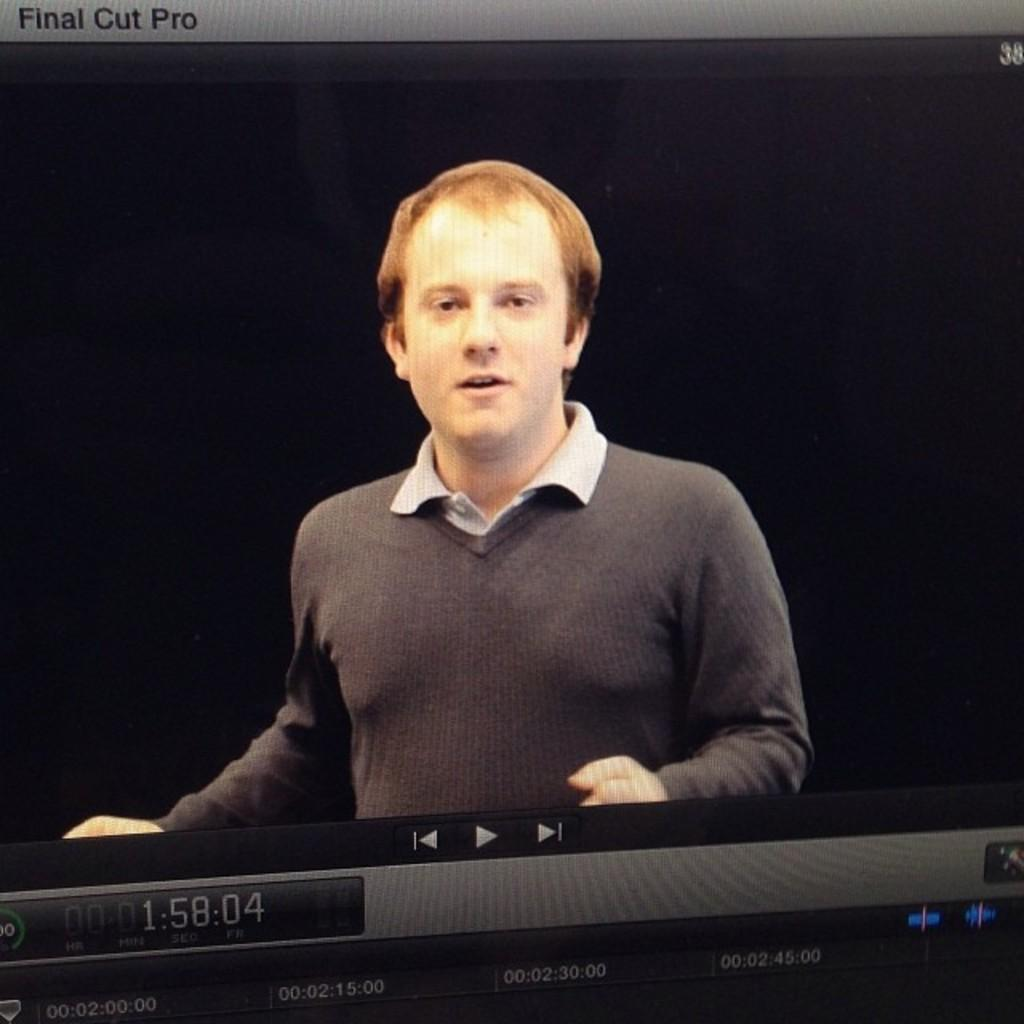What is the main object in the image? There is a screen in the image. What can be seen on the screen? A person is visible on the screen. How many hens are visible on the tray in the image? There is no tray or hens present in the image. What type of crowd can be seen gathering around the screen in the image? There is no crowd visible in the image; it only shows a screen with a person on it. 